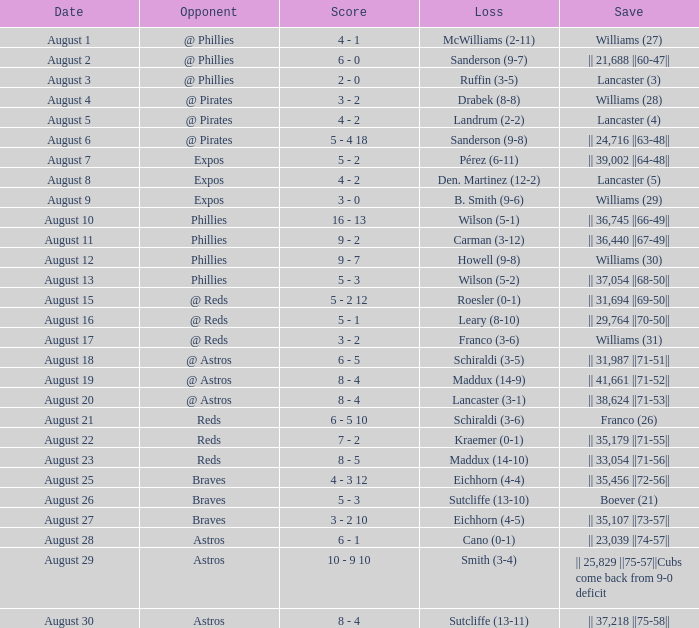Name the score for save of lancaster (3) 2 - 0. 